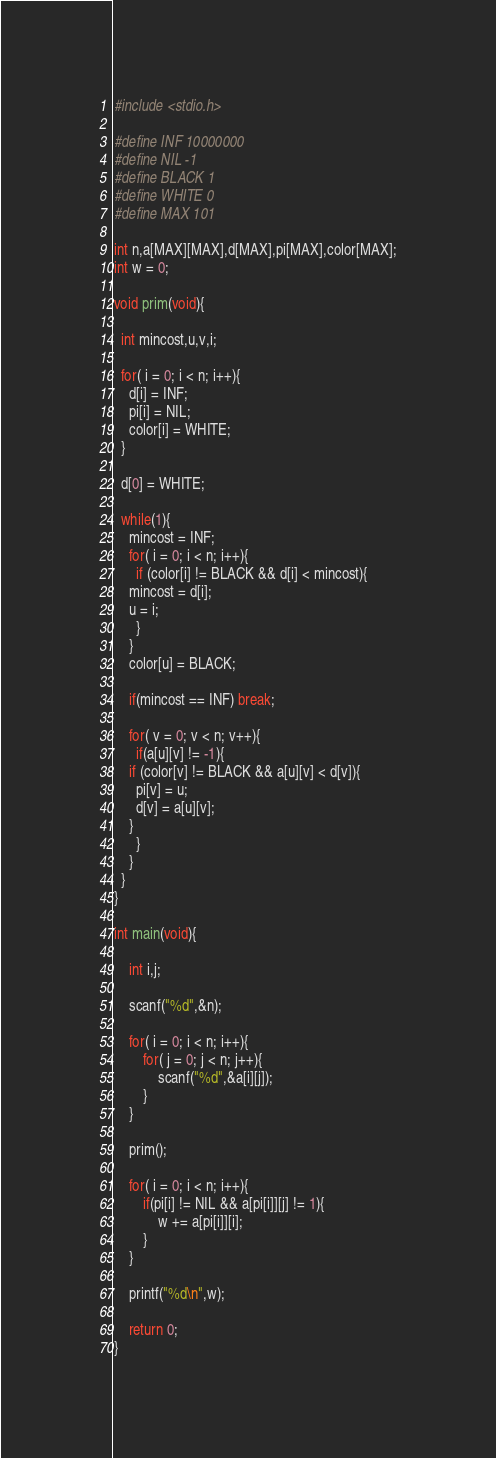<code> <loc_0><loc_0><loc_500><loc_500><_C_>#include <stdio.h>

#define INF 10000000
#define NIL -1
#define BLACK 1
#define WHITE 0
#define MAX 101

int n,a[MAX][MAX],d[MAX],pi[MAX],color[MAX];
int w = 0;

void prim(void){

  int mincost,u,v,i;
 
  for( i = 0; i < n; i++){ 
    d[i] = INF;
    pi[i] = NIL;
    color[i] = WHITE;
  }
 
  d[0] = WHITE;
 
  while(1){
    mincost = INF;
    for( i = 0; i < n; i++){ 
      if (color[i] != BLACK && d[i] < mincost){
    mincost = d[i];
    u = i;
      }
    }
    color[u] = BLACK;
 
    if(mincost == INF) break;
 
    for( v = 0; v < n; v++){
      if(a[u][v] != -1){
    if (color[v] != BLACK && a[u][v] < d[v]){
      pi[v] = u;
      d[v] = a[u][v];
    }
      }
    }
  }
}

int main(void){

	int i,j;

	scanf("%d",&n);

	for( i = 0; i < n; i++){
		for( j = 0; j < n; j++){
			scanf("%d",&a[i][j]);
		}
	}

	prim();

	for( i = 0; i < n; i++){
		if(pi[i] != NIL && a[pi[i]][j] != 1){
			w += a[pi[i]][i];
		}  
	}

	printf("%d\n",w);

	return 0;
}</code> 